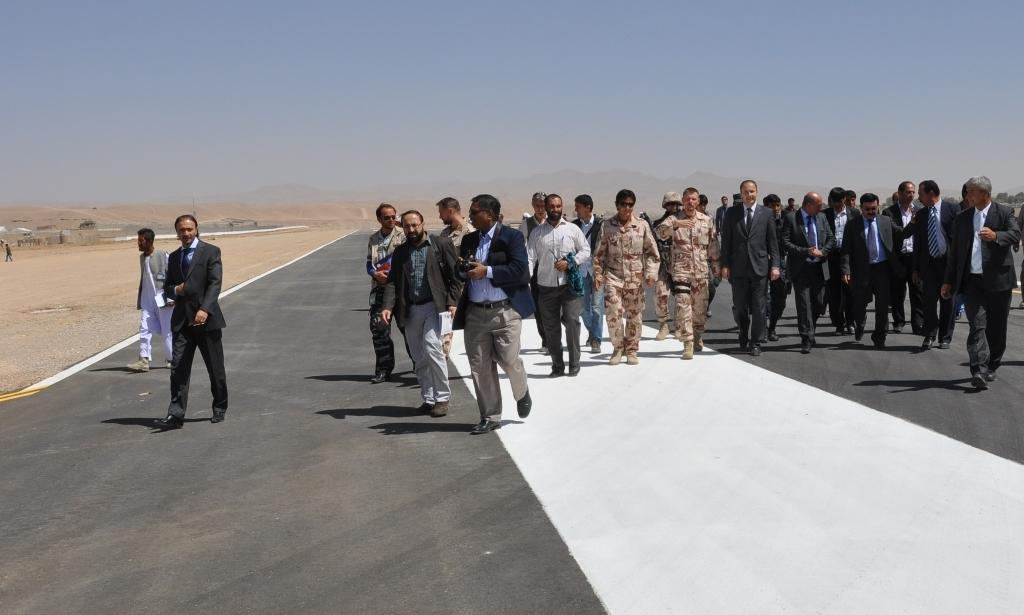How many people are in the image? There is a group of people in the image. Where are the people located in the image? The people are standing on the road. What type of landscape can be seen in the image? Hills are visible in the image. What is visible in the background of the image? The sky is visible in the background of the image. What type of church can be seen in the image? There is no church present in the image. What color is the underwear worn by the people in the image? We cannot determine the color of any underwear worn by the people in the image, as they are not visible. 